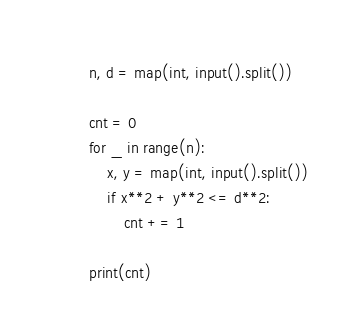Convert code to text. <code><loc_0><loc_0><loc_500><loc_500><_Python_>n, d = map(int, input().split())

cnt = 0
for _ in range(n):
    x, y = map(int, input().split())
    if x**2 + y**2 <= d**2:
        cnt += 1

print(cnt)</code> 